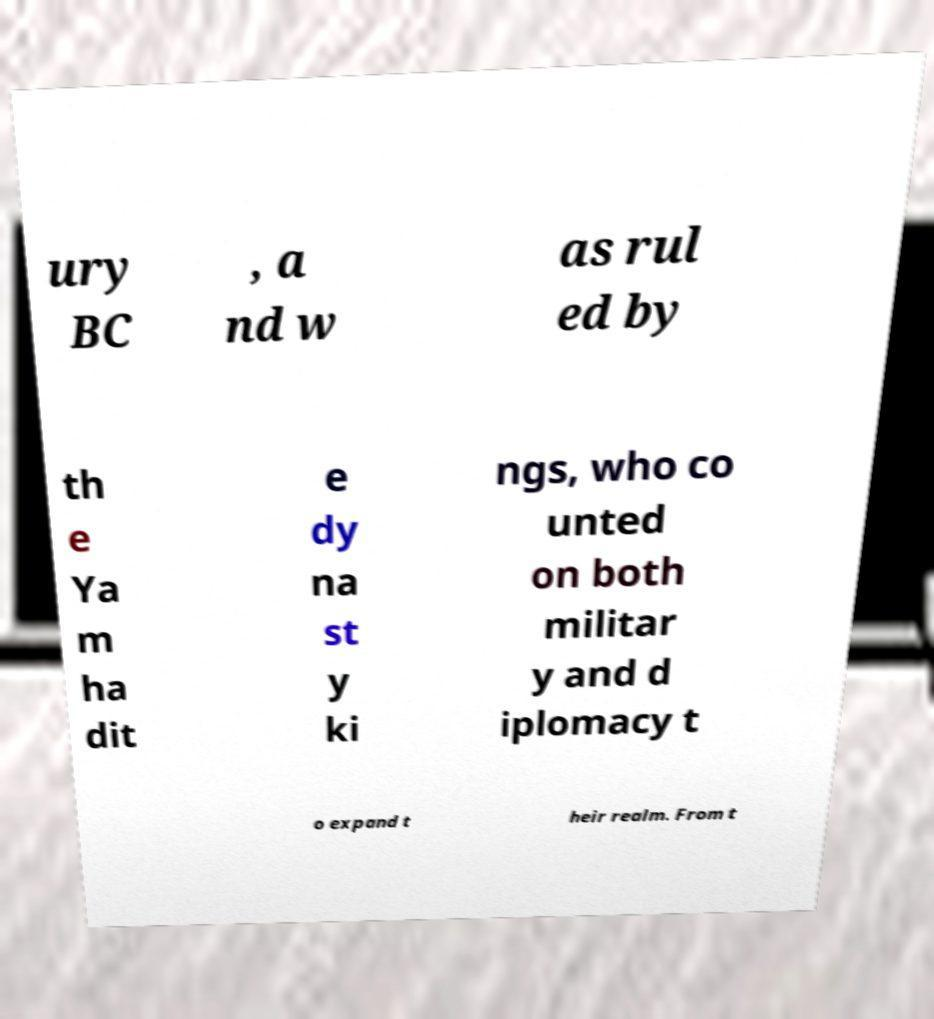What messages or text are displayed in this image? I need them in a readable, typed format. ury BC , a nd w as rul ed by th e Ya m ha dit e dy na st y ki ngs, who co unted on both militar y and d iplomacy t o expand t heir realm. From t 